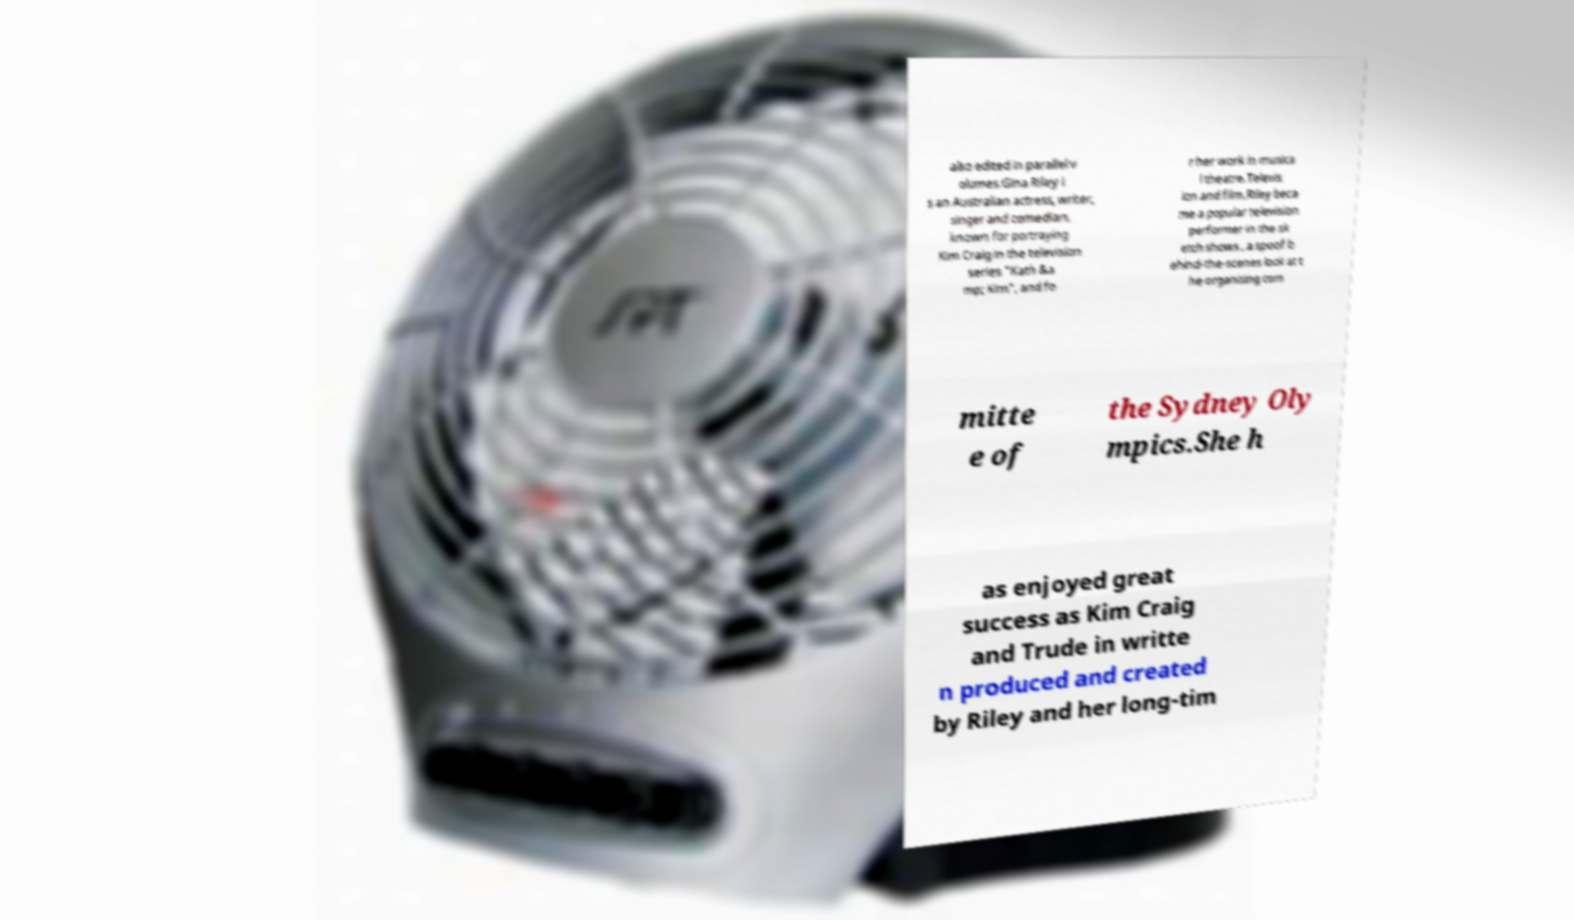I need the written content from this picture converted into text. Can you do that? also edited in parallel v olumes.Gina Riley i s an Australian actress, writer, singer and comedian, known for portraying Kim Craig in the television series "Kath &a mp; Kim", and fo r her work in musica l theatre.Televis ion and film.Riley beca me a popular television performer in the sk etch shows , a spoof b ehind-the-scenes look at t he organising com mitte e of the Sydney Oly mpics.She h as enjoyed great success as Kim Craig and Trude in writte n produced and created by Riley and her long-tim 